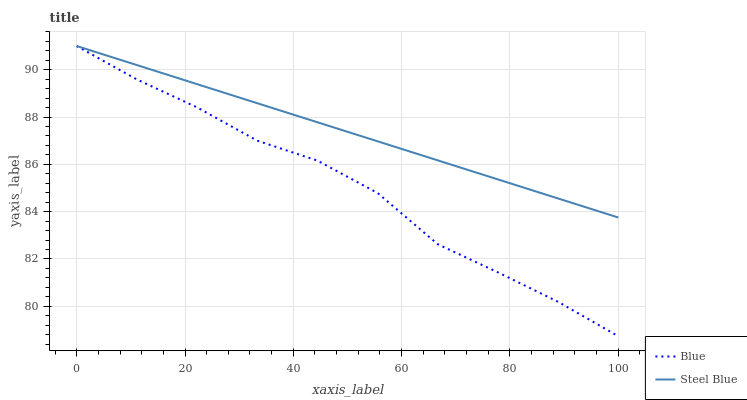Does Blue have the minimum area under the curve?
Answer yes or no. Yes. Does Steel Blue have the maximum area under the curve?
Answer yes or no. Yes. Does Steel Blue have the minimum area under the curve?
Answer yes or no. No. Is Steel Blue the smoothest?
Answer yes or no. Yes. Is Blue the roughest?
Answer yes or no. Yes. Is Steel Blue the roughest?
Answer yes or no. No. Does Blue have the lowest value?
Answer yes or no. Yes. Does Steel Blue have the lowest value?
Answer yes or no. No. Does Steel Blue have the highest value?
Answer yes or no. Yes. Does Blue intersect Steel Blue?
Answer yes or no. Yes. Is Blue less than Steel Blue?
Answer yes or no. No. Is Blue greater than Steel Blue?
Answer yes or no. No. 